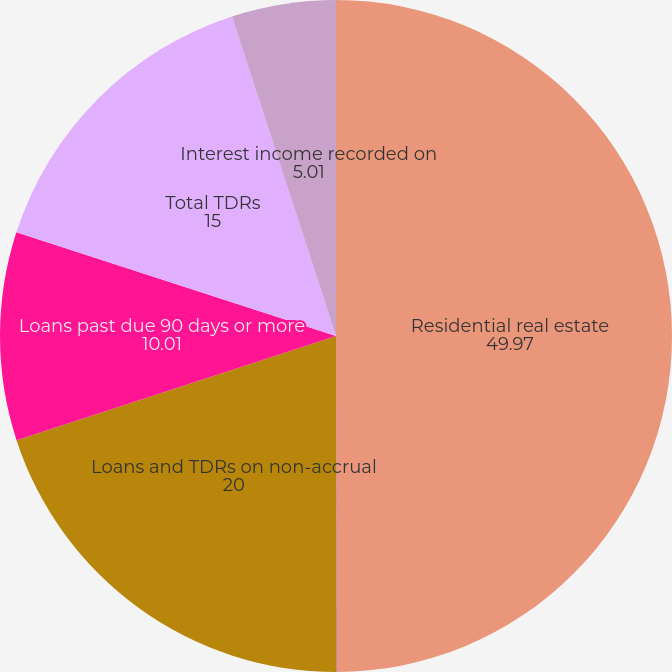<chart> <loc_0><loc_0><loc_500><loc_500><pie_chart><fcel>Residential real estate<fcel>Home equity lines of credit<fcel>Loans and TDRs on non-accrual<fcel>Loans past due 90 days or more<fcel>Total TDRs<fcel>Interest income recorded on<nl><fcel>49.97%<fcel>0.02%<fcel>20.0%<fcel>10.01%<fcel>15.0%<fcel>5.01%<nl></chart> 